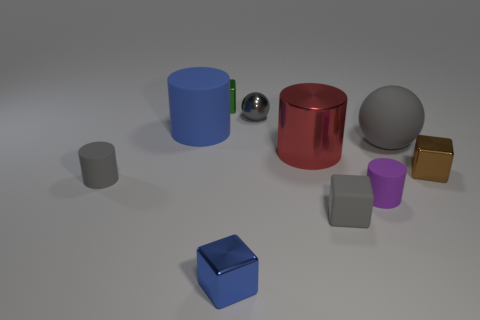Subtract all balls. How many objects are left? 8 Add 5 large blue matte objects. How many large blue matte objects are left? 6 Add 10 tiny yellow spheres. How many tiny yellow spheres exist? 10 Subtract 1 gray blocks. How many objects are left? 9 Subtract all purple cylinders. Subtract all blue things. How many objects are left? 7 